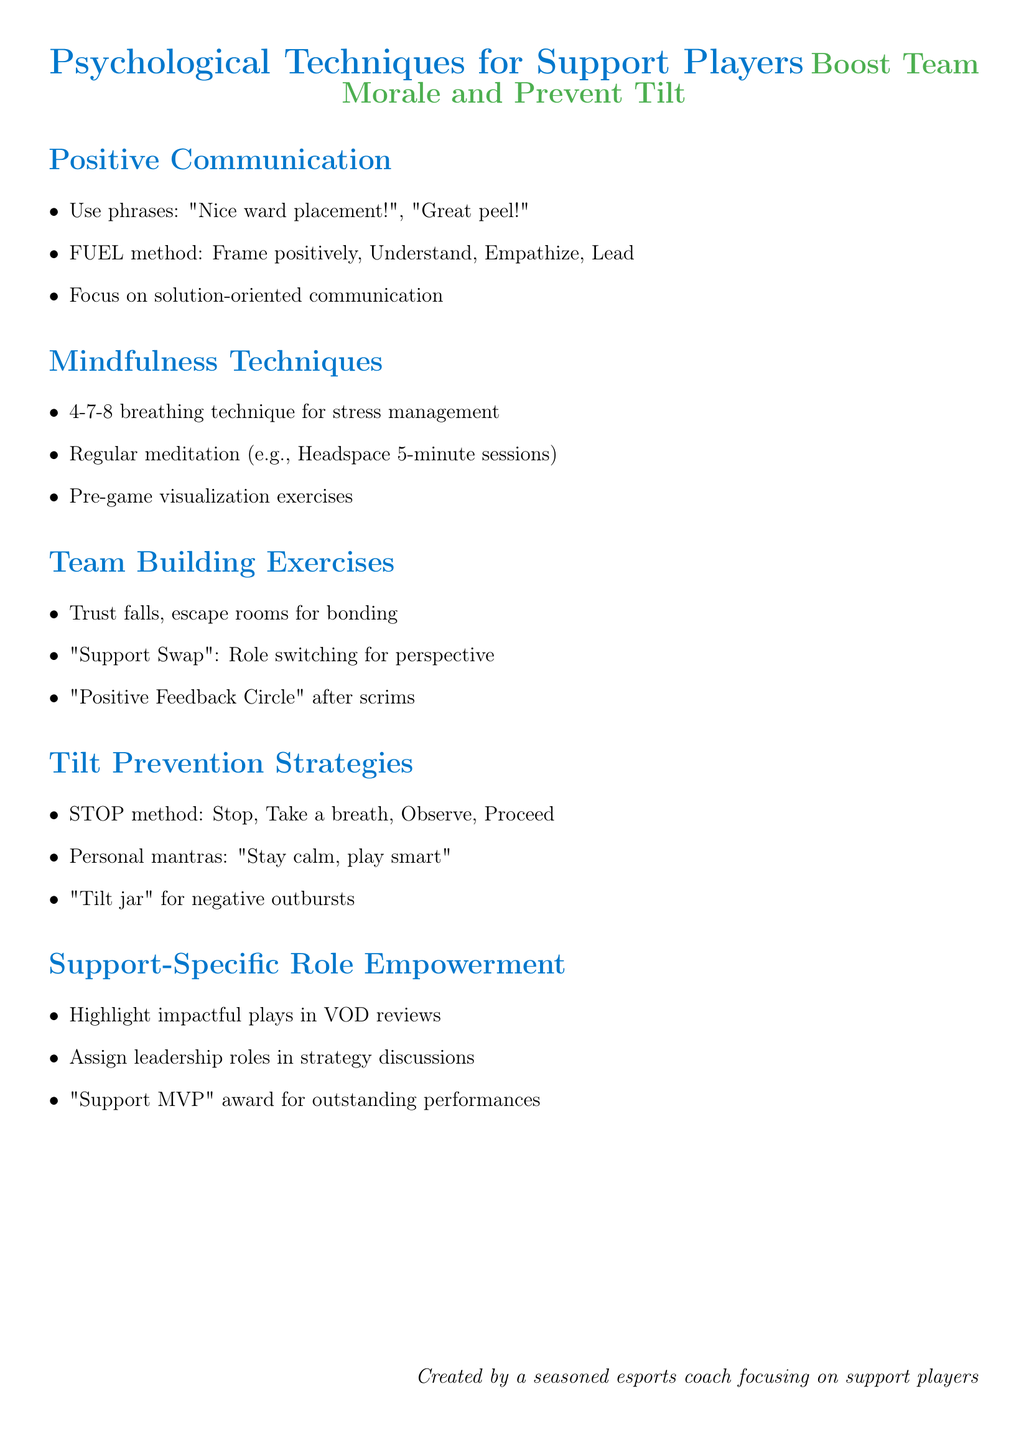what is one example of encouraging phrase for support players? The document lists "Nice ward placement!" as an example of an encouraging phrase.
Answer: Nice ward placement! what does the FUEL method stand for? The FUEL method involves four steps: Frame positively, Understand the situation, Empathize, Lead by example.
Answer: Frame positively, Understand the situation, Empathize, Lead by example what breathing technique is suggested for stress management? The document recommends the 4-7-8 breathing technique for stress management during intense matches.
Answer: 4-7-8 breathing technique name one team building exercise mentioned. The document mentions trust falls as one of the team building exercises to strengthen bonds.
Answer: Trust falls what is the STOP method? The STOP method is a strategy to help manage tilt: Stop, Take a breath, Observe, Proceed.
Answer: Stop, Take a breath, Observe, Proceed what is the purpose of the "tilt jar"? The tilt jar is used for players to put money in for negative outbursts, which is then used for team activities.
Answer: For team activities how can support players be empowered according to the document? The document suggests creating a "Support MVP" award for outstanding performances as a way to empower support players.
Answer: "Support MVP" award what is one mindfulness technique mentioned? Regular meditation practices, such as using the Headspace app's 5-minute sessions, are suggested as a mindfulness technique.
Answer: Headspace app's 5-minute sessions what exercise helps players understand each other's perspectives? The "Support Swap" exercise helps players switch roles to understand each other's perspectives.
Answer: Support Swap 